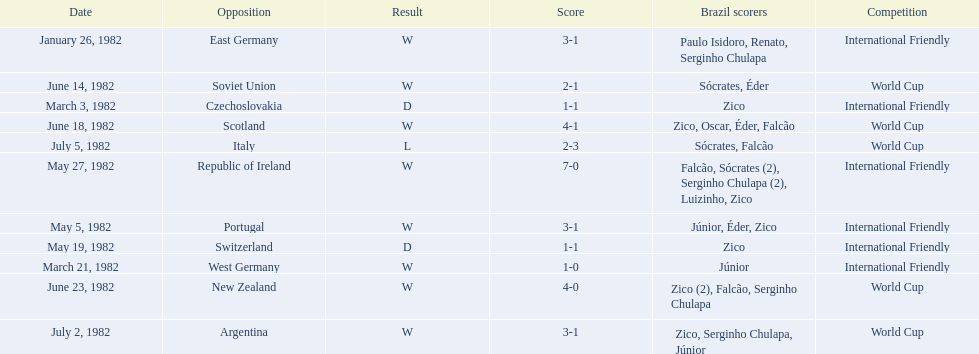Who won on january 26, 1982 and may 27, 1982? Brazil. 